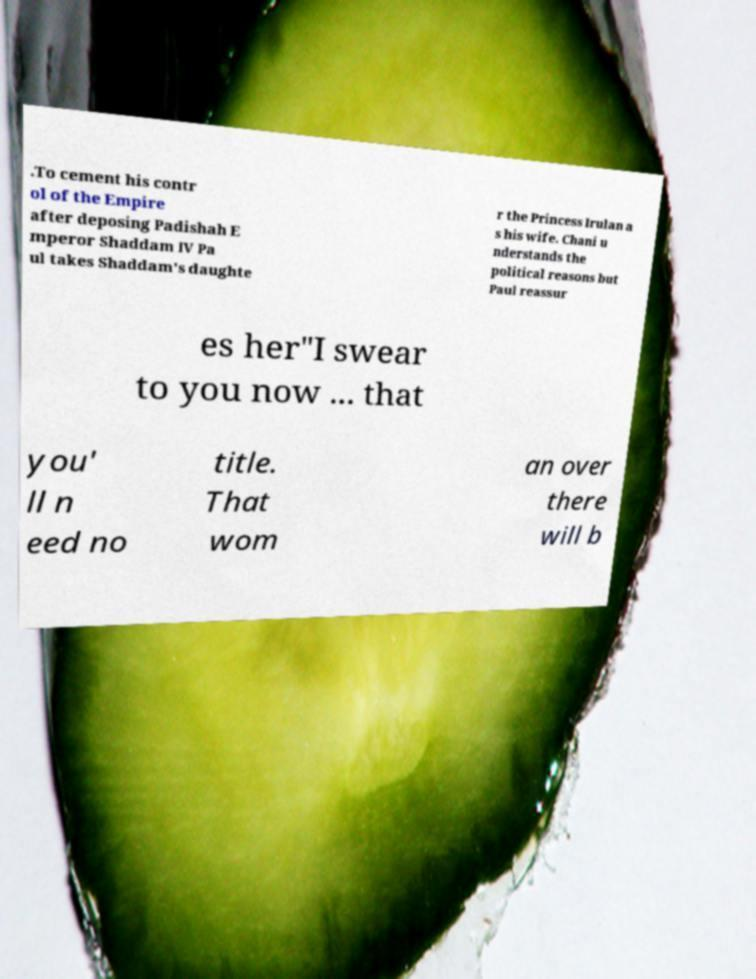For documentation purposes, I need the text within this image transcribed. Could you provide that? .To cement his contr ol of the Empire after deposing Padishah E mperor Shaddam IV Pa ul takes Shaddam's daughte r the Princess Irulan a s his wife. Chani u nderstands the political reasons but Paul reassur es her"I swear to you now ... that you' ll n eed no title. That wom an over there will b 